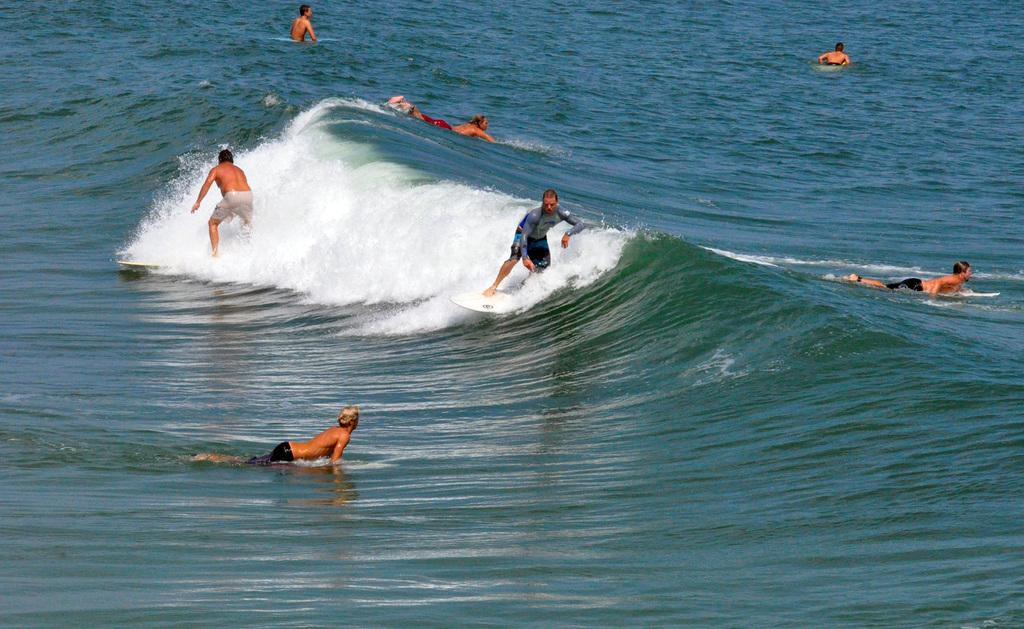Who or what can be seen in the image? There are people in the image. What are the people doing in the image? The people are surfing in water. What type of mark can be seen on the surfboard in the image? There is no mark mentioned or visible on the surfboard in the image. 